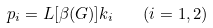Convert formula to latex. <formula><loc_0><loc_0><loc_500><loc_500>p _ { i } = L [ \beta ( G ) ] k _ { i } \quad ( i = 1 , 2 )</formula> 